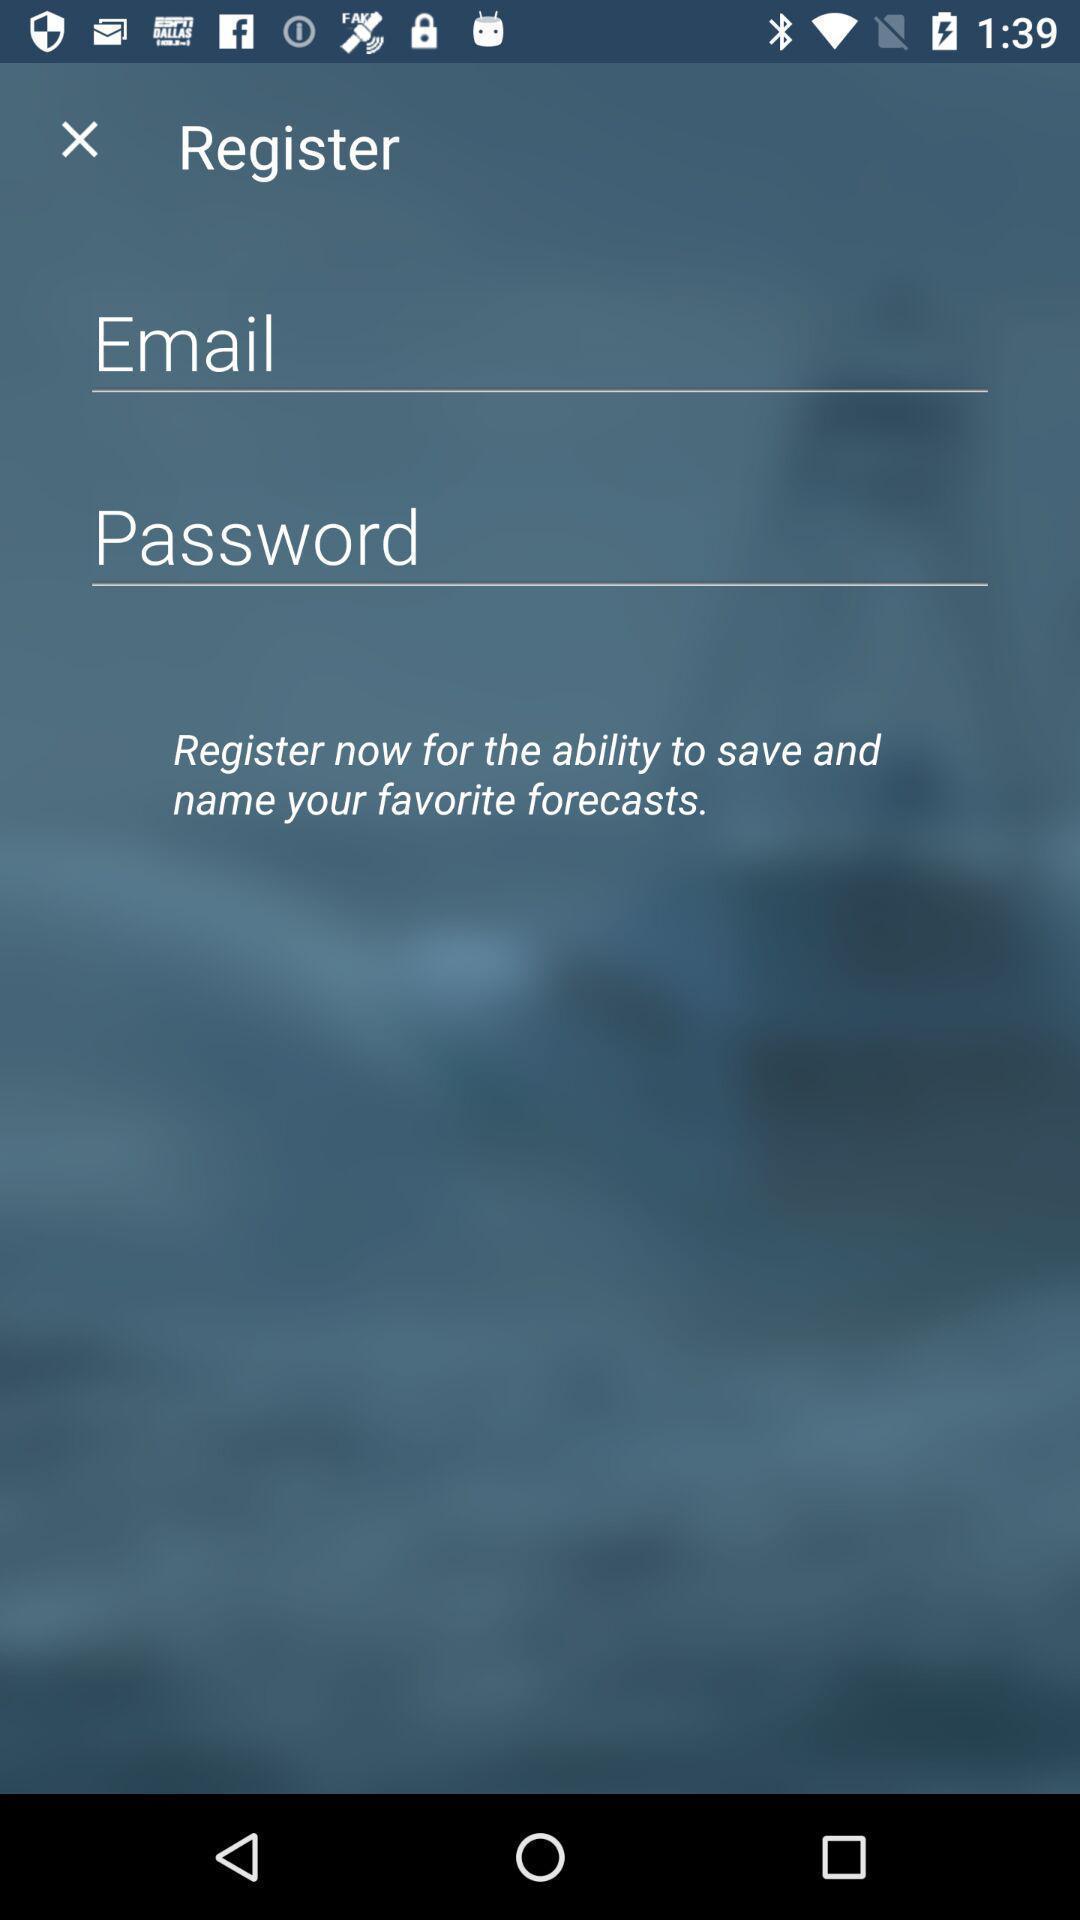Summarize the information in this screenshot. Signup page. 